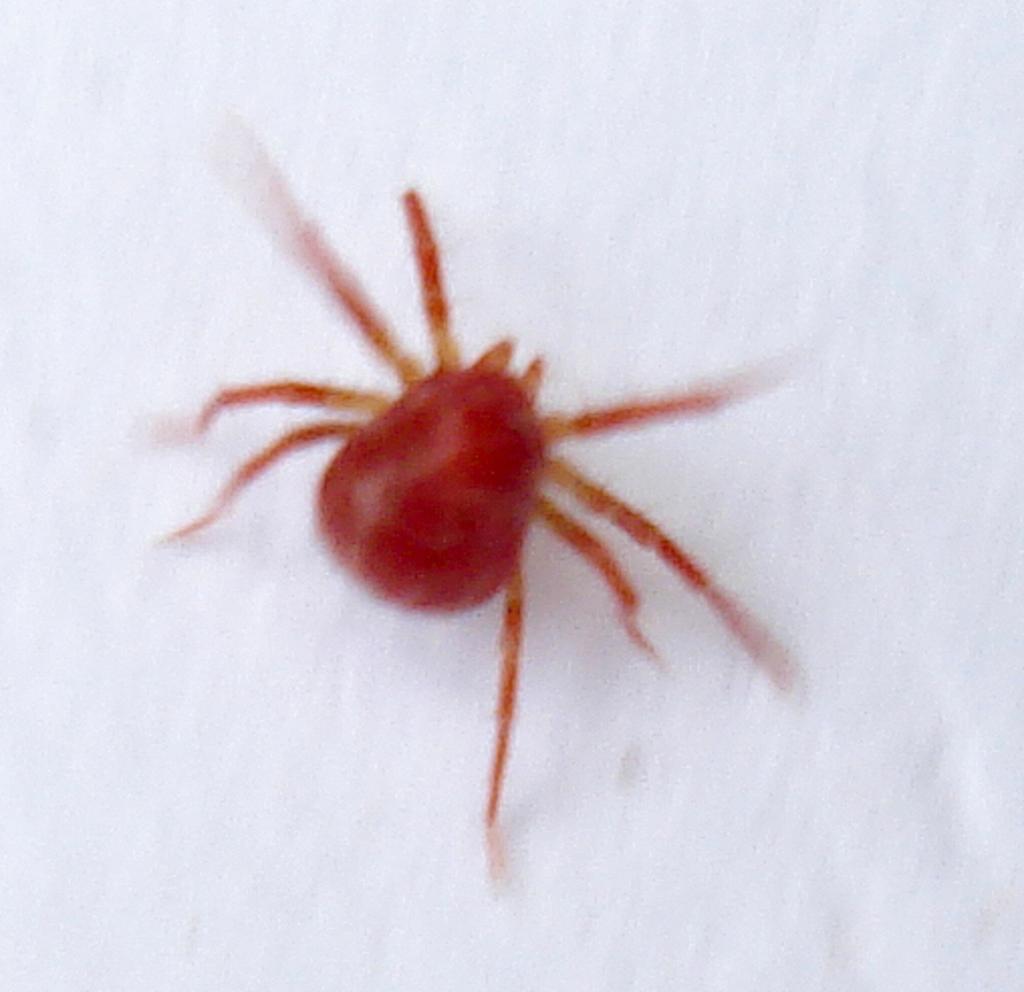Can you describe this image briefly? In the picture there is a red color spider and the background of the spider is white. 